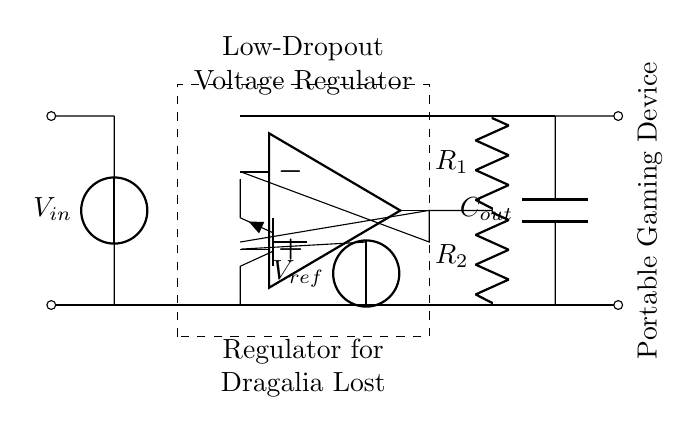What does the dashed rectangle represent? The dashed rectangle visually indicates the boundaries of the low-dropout voltage regulator, encapsulating its internal components like the pass transistor and error amplifier.
Answer: Low-Dropout Voltage Regulator What is the function of the pass transistor? The pass transistor in the circuit regulates the output voltage by allowing current to flow from input to output while controlling the voltage drop across it, ensuring that the voltage remains stable despite variations in input voltage or load current.
Answer: Stabilizes output voltage What is the reference voltage in this circuit? The reference voltage is a fixed voltage level that the regulator uses as a baseline for adjusting the output voltage; here it is labeled as V ref in the circuit diagram.
Answer: V ref How many resistors are present in the feedback network? The feedback network consists of two resistors that are used to set the output voltage of the regulator by providing feedback to the error amplifier.
Answer: Two What is the intended load for this voltage regulator? The labeled "Portable Gaming Device" indicates that the regulator is designed to provide a stable voltage to a gaming device, ensuring that it operates properly without fluctuations in power supply.
Answer: Portable Gaming Device What role does the output capacitor play? The output capacitor helps smooth out the voltage at the output, reducing voltage ripple and ensuring a stable voltage supply to the load, thereby enhancing the performance of the regulator.
Answer: Smoothing voltage 